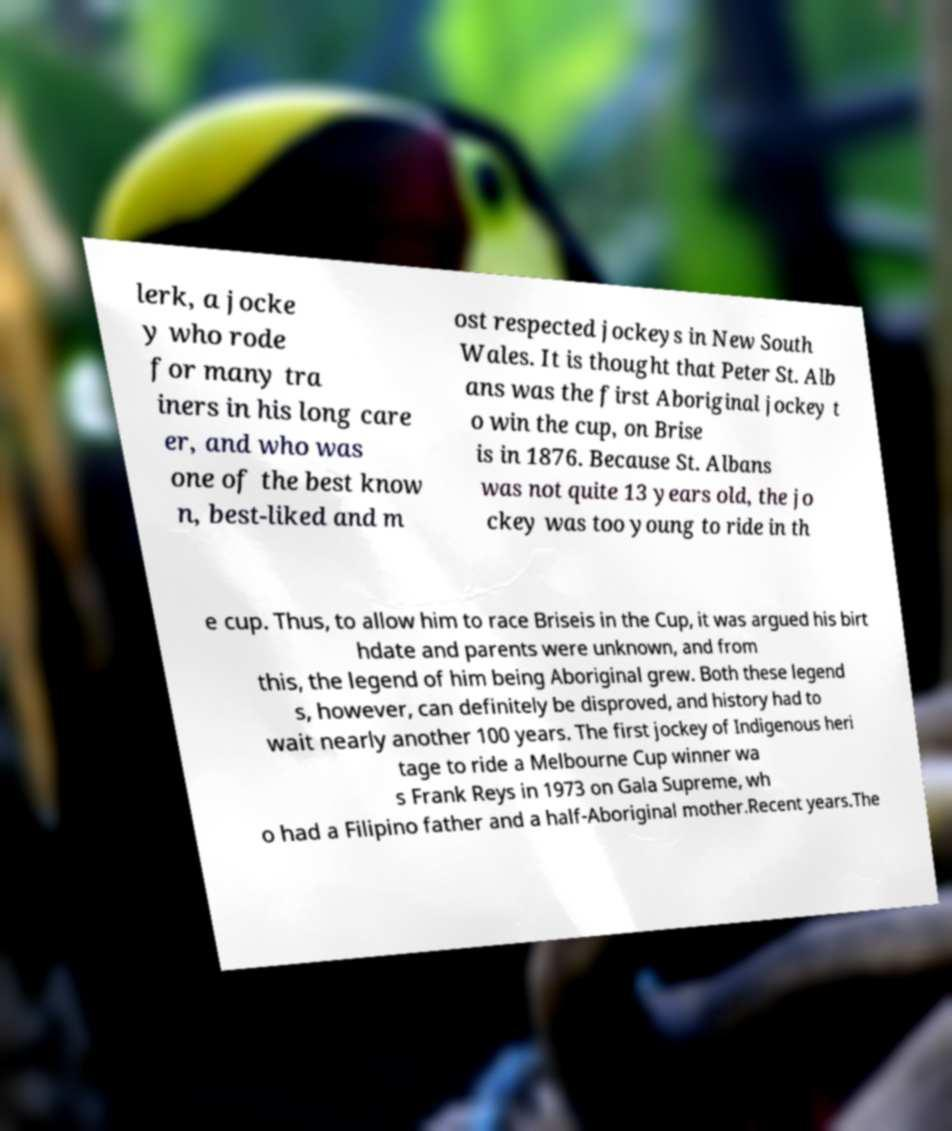Could you assist in decoding the text presented in this image and type it out clearly? lerk, a jocke y who rode for many tra iners in his long care er, and who was one of the best know n, best-liked and m ost respected jockeys in New South Wales. It is thought that Peter St. Alb ans was the first Aboriginal jockey t o win the cup, on Brise is in 1876. Because St. Albans was not quite 13 years old, the jo ckey was too young to ride in th e cup. Thus, to allow him to race Briseis in the Cup, it was argued his birt hdate and parents were unknown, and from this, the legend of him being Aboriginal grew. Both these legend s, however, can definitely be disproved, and history had to wait nearly another 100 years. The first jockey of Indigenous heri tage to ride a Melbourne Cup winner wa s Frank Reys in 1973 on Gala Supreme, wh o had a Filipino father and a half-Aboriginal mother.Recent years.The 